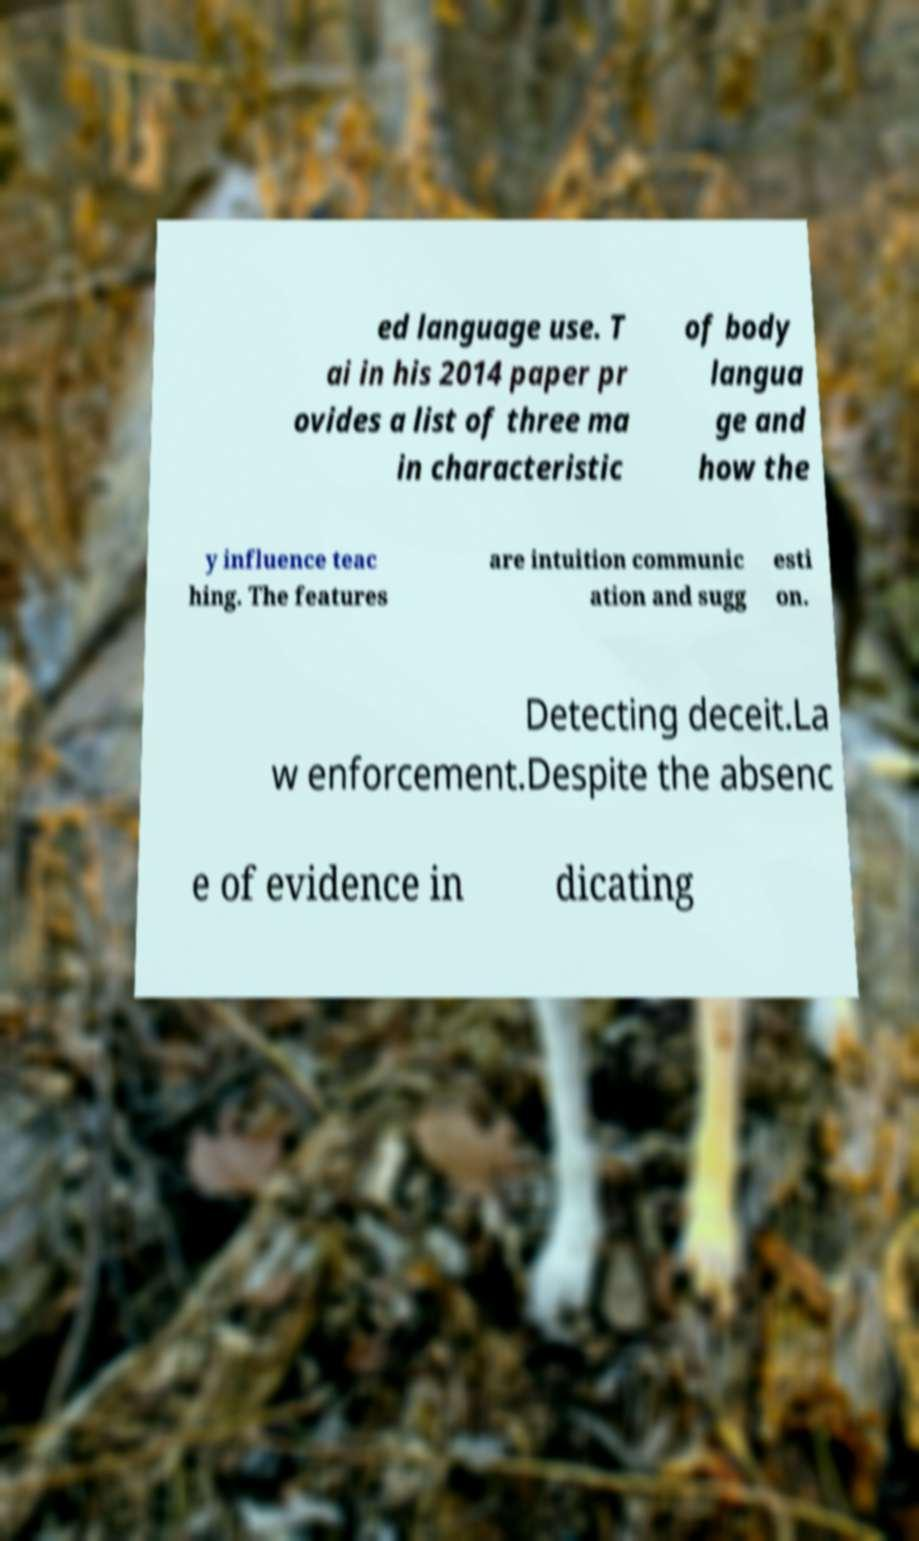I need the written content from this picture converted into text. Can you do that? ed language use. T ai in his 2014 paper pr ovides a list of three ma in characteristic of body langua ge and how the y influence teac hing. The features are intuition communic ation and sugg esti on. Detecting deceit.La w enforcement.Despite the absenc e of evidence in dicating 